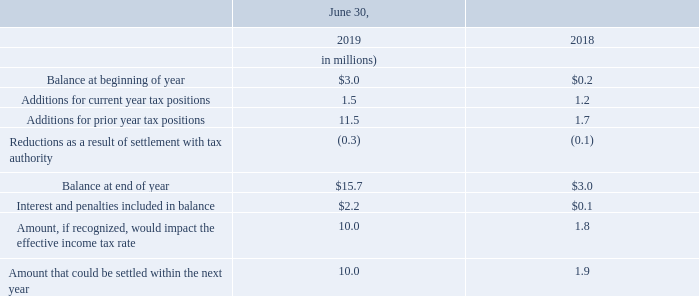The Company had gross unrecognized tax benefits of $15.7 million and $3.0 million, as of June 30, 2019 and June 30, 2018, respectively. The Company recognizes interest and penalties related to uncertain tax positions in income tax expense.
The Company files income tax returns in various federal, state, and local jurisdictions including the United States, Canada, United Kingdom and France. In the normal course of business, the Company is subject to examination by taxing authorities throughout the world. With few exceptions, the Company is no longer subject to income tax examinations by tax authorities in major tax jurisdictions for years before 2014.
Where does the company file income tax returns? In various federal, state, and local jurisdictions including the united states, canada, united kingdom and france. How much gross unrecognized tax benefits did the company have as of June 30, 2019? $15.7 million. Which years is the company no longer subject to income tax examinations by tax authorities in major tax jurisdictions? For years before 2014. What is the % change in the balance at end of year from 2018 to 2019?
Answer scale should be: percent. (15.7-3.0)/3.0
Answer: 423.33. What is the average beginning balance for the years 2018 to 2019?
Answer scale should be: million. (3.0+0.2)/(2019-2018+1)
Answer: 1.6. Which years had additions for current year tax positions of more than 1.1 million? 1.5 > 1.2 > 1.1
Answer: 2018, 2019. 